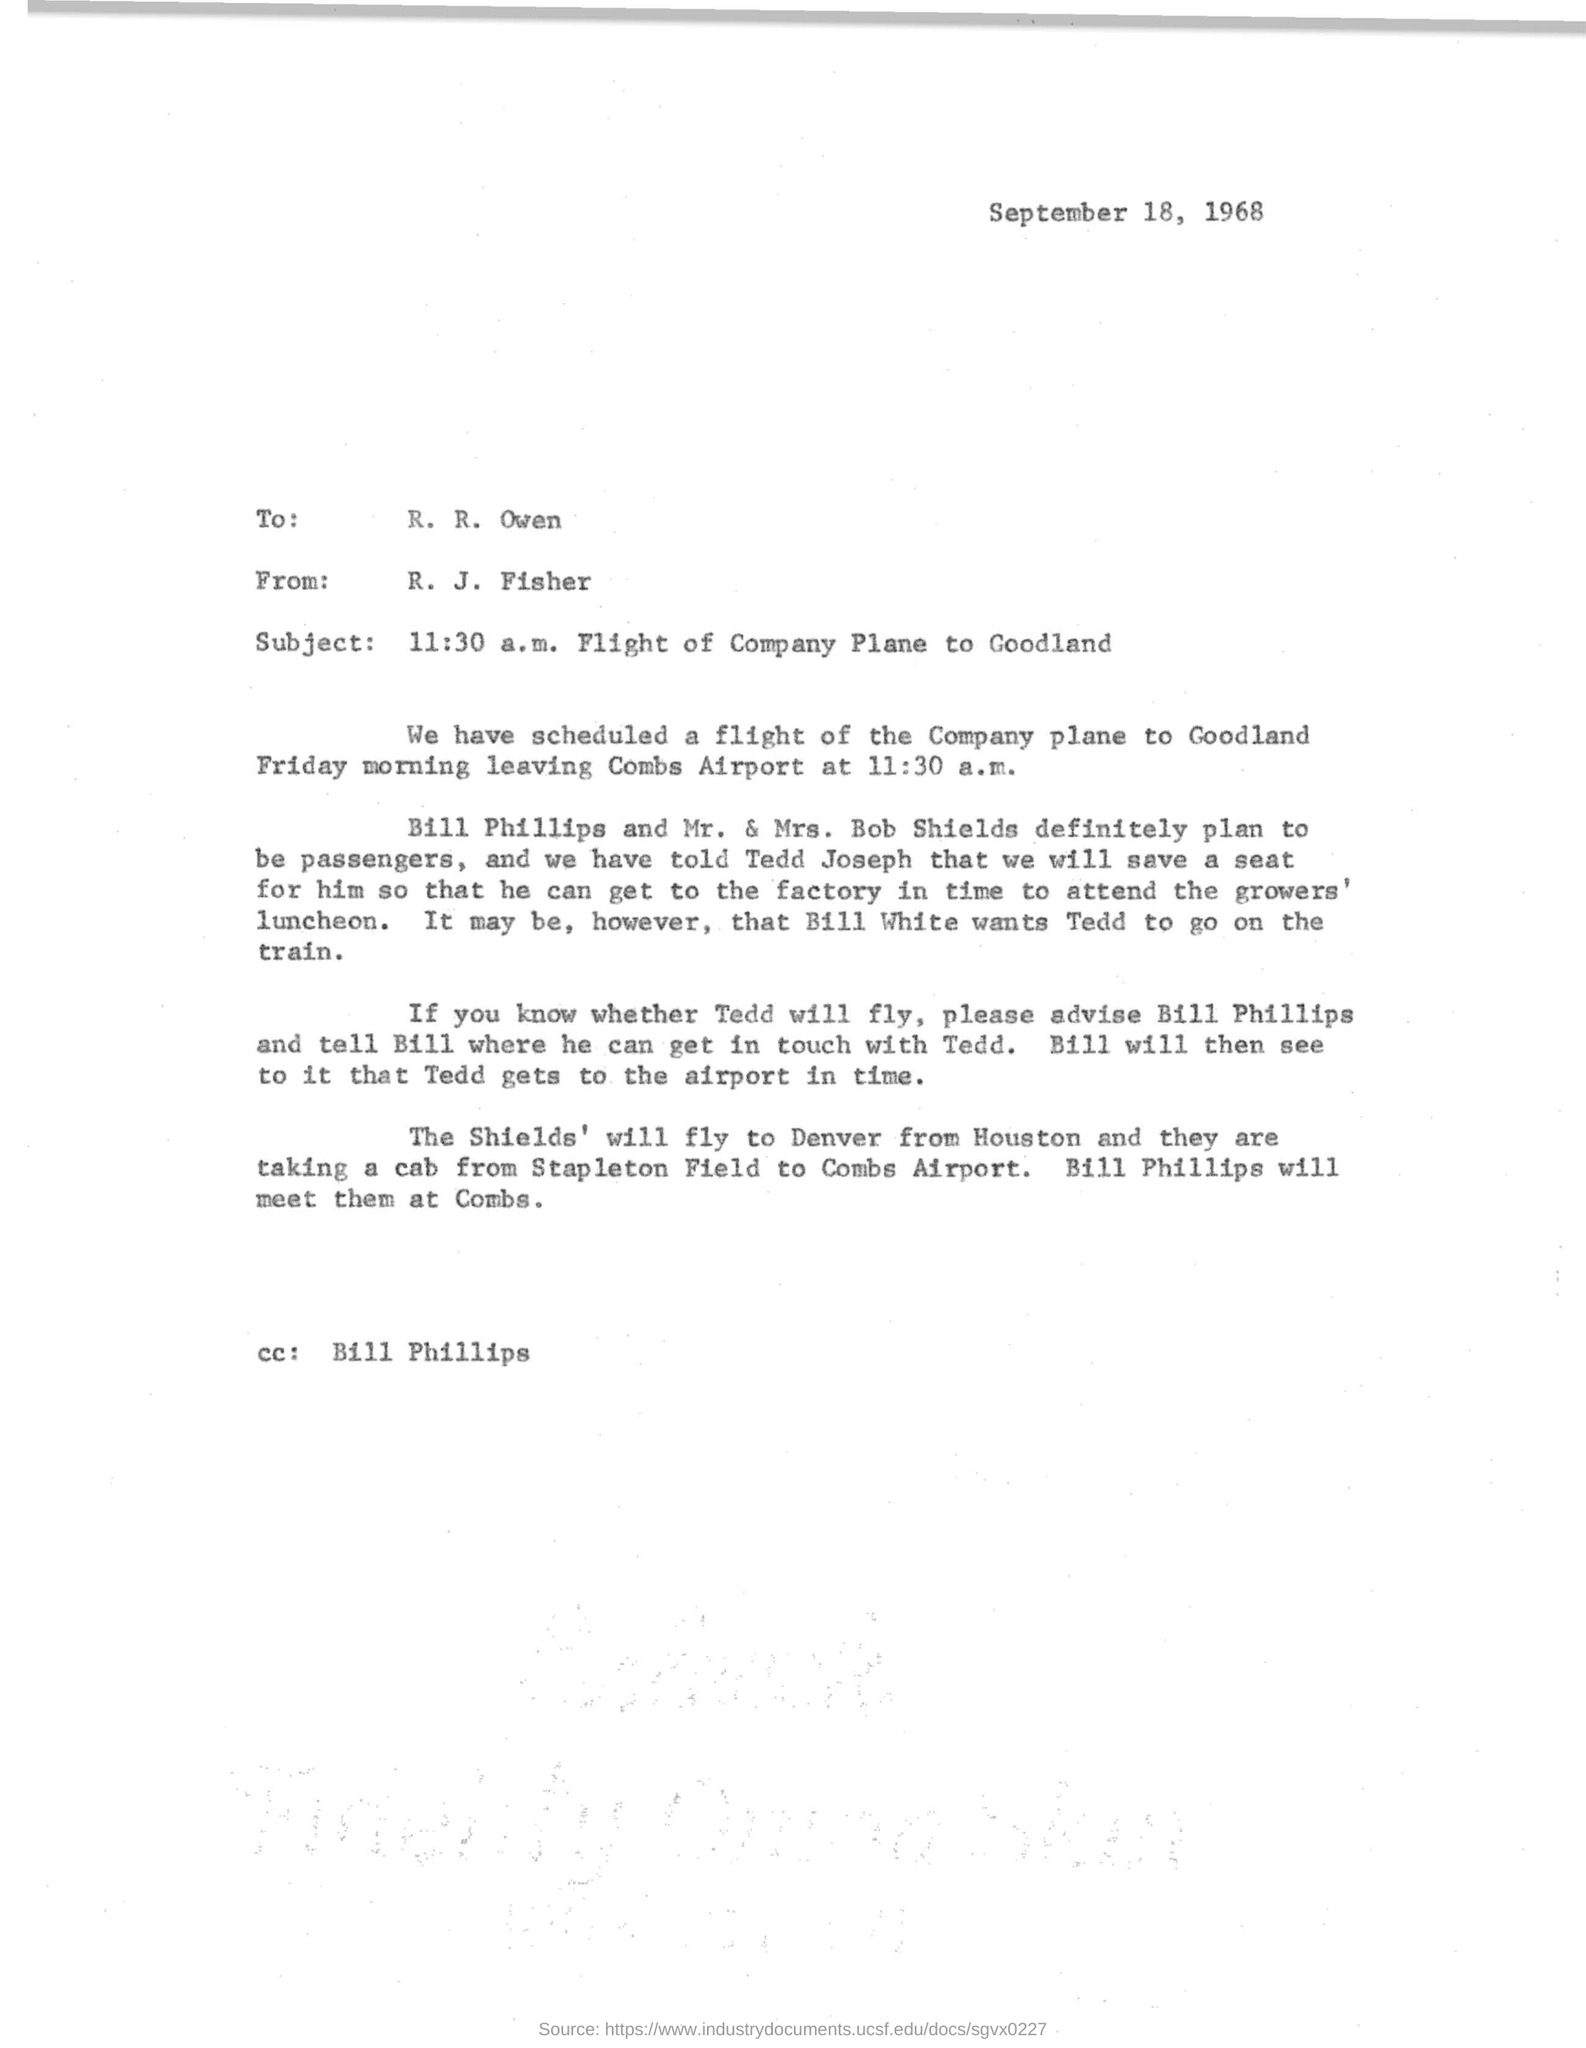List a handful of essential elements in this visual. The sender of the letter is R. J. Fisher. The flight is scheduled to depart at 11:30 a.m. The flight is scheduled to depart from Combs Airport. It is necessary for Tedd Joseph to attend the growers' luncheon. The flight destination is Goodland. 